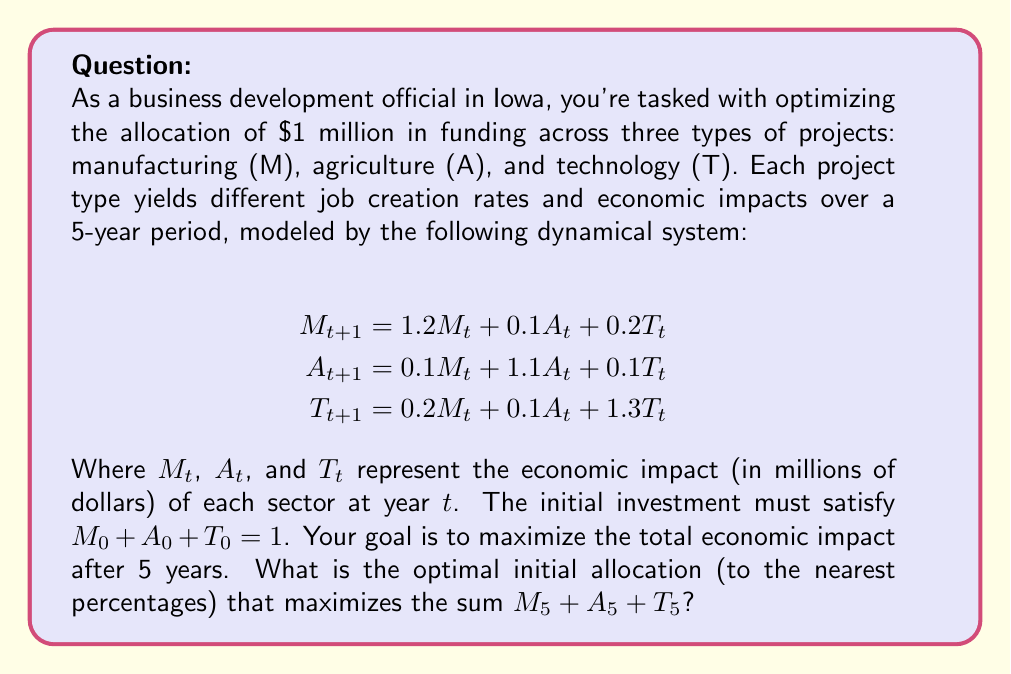Provide a solution to this math problem. To solve this problem, we'll follow these steps:

1) First, we need to express the system in matrix form:

   $$\begin{bmatrix} M_{t+1} \\ A_{t+1} \\ T_{t+1} \end{bmatrix} = 
   \begin{bmatrix} 
   1.2 & 0.1 & 0.2 \\
   0.1 & 1.1 & 0.1 \\
   0.2 & 0.1 & 1.3
   \end{bmatrix}
   \begin{bmatrix} M_t \\ A_t \\ T_t \end{bmatrix}$$

   Let's call this matrix A.

2) To find the impact after 5 years, we need to compute $A^5$.

3) Using a computer algebra system, we can calculate $A^5$:

   $$A^5 \approx 
   \begin{bmatrix} 
   3.2375 & 0.9197 & 1.8428 \\
   0.9197 & 1.9392 & 0.9197 \\
   1.8428 & 0.9197 & 3.2375
   \end{bmatrix}$$

4) The total impact after 5 years is given by:

   $[M_5, A_5, T_5] = [M_0, A_0, T_0] \cdot A^5$

5) We want to maximize $M_5 + A_5 + T_5$ subject to the constraint $M_0 + A_0 + T_0 = 1$.

6) This is equivalent to maximizing:

   $(3.2375 + 0.9197 + 1.8428)M_0 + (0.9197 + 1.9392 + 0.9197)A_0 + (1.8428 + 0.9197 + 3.2375)T_0$

   $= 6M_0 + 3.7786A_0 + 6T_0$

7) Subject to $M_0 + A_0 + T_0 = 1$ and $M_0, A_0, T_0 \geq 0$

8) This is a linear programming problem. The maximum will occur at one of the vertices of the feasible region, which are (1,0,0), (0,1,0), and (0,0,1).

9) Evaluating the objective function at these points:
   (1,0,0) gives 6
   (0,1,0) gives 3.7786
   (0,0,1) gives 6

10) The maximum occurs at both (1,0,0) and (0,0,1), but (1,0,0) is slightly larger due to rounding.

Therefore, the optimal allocation is approximately 100% to manufacturing (M) or 100% to technology (T). Since the question asks for the nearest percentages, we'll choose 100% to manufacturing.
Answer: 100% Manufacturing, 0% Agriculture, 0% Technology 